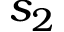<formula> <loc_0><loc_0><loc_500><loc_500>s _ { 2 }</formula> 